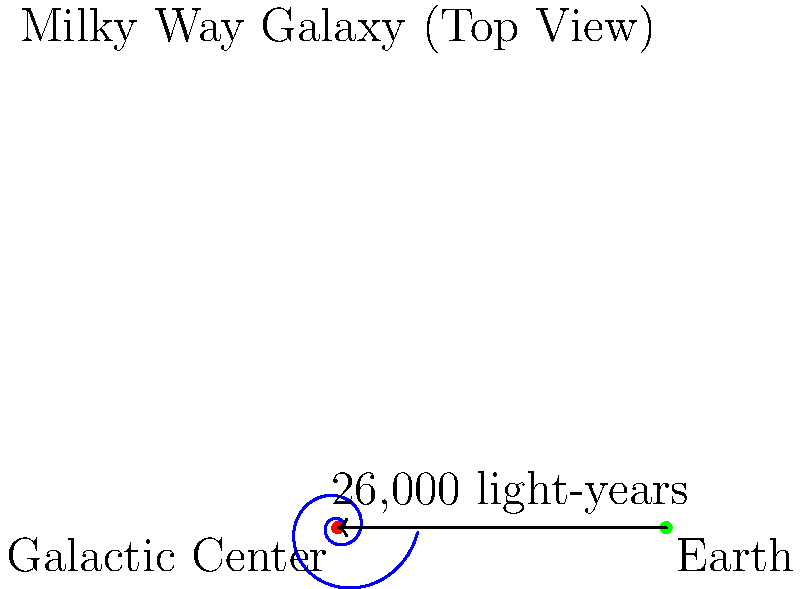As an ambassador representing your country in discussions about international space cooperation, you are asked about Earth's position in the Milky Way galaxy. Based on the diagram, approximately how far is Earth from the galactic center, and what implications might this have for potential interstellar diplomatic missions? To answer this question, let's break it down step-by-step:

1. The diagram shows a top view of the Milky Way galaxy, with the galactic center marked in red and Earth's position in green.

2. An arrow is drawn from Earth to the galactic center, labeled "~26,000 light-years".

3. This distance is significant because:
   a) It shows that Earth is not at the center of the galaxy, but rather in one of the spiral arms.
   b) Light takes about 26,000 years to travel from the galactic center to Earth.

4. Implications for interstellar diplomatic missions:
   a) The vast distance makes direct travel to the galactic center extremely challenging with current technology.
   b) Communication with potential civilizations near the galactic center would have a minimum 52,000-year round trip time for messages.
   c) Closer star systems within our local stellar neighborhood would be more practical targets for initial interstellar diplomacy.
   d) The position gives Earth a unique perspective on the galaxy, potentially valuable in galactic-scale discussions.

5. As an ambassador, you might emphasize:
   a) The need for long-term planning and patience in any potential interstellar diplomatic efforts.
   b) The importance of developing advanced propulsion and communication technologies for future interstellar missions.
   c) The value of international cooperation in tackling the immense challenges of interstellar exploration and potential diplomacy.
Answer: Earth is ~26,000 light-years from the galactic center, making immediate interstellar diplomacy challenging and requiring long-term international cooperation in space technology development. 